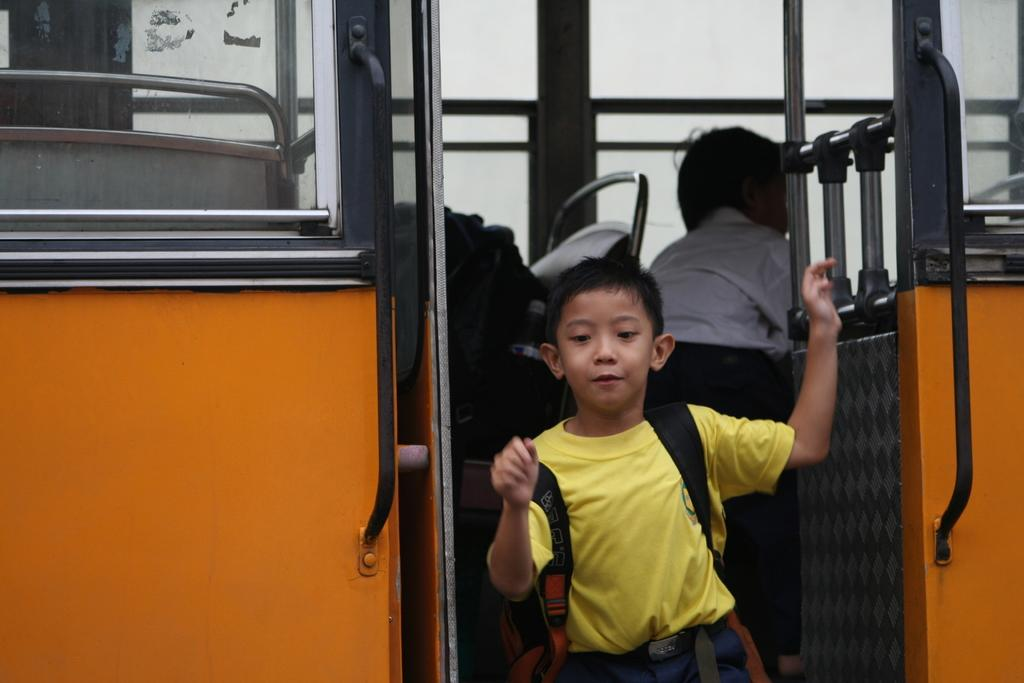Who is the main subject in the image? There is a boy in the image. What is the boy doing in the image? The boy is getting down from a bus. Is there anyone else present in the image? Yes, there is another boy standing behind him. What type of pen is the boy holding in the image? There is no pen present in the image; the boy is getting down from a bus. How does the fish react to the boy's presence in the image? There is no fish present in the image, so it cannot react to the boy's presence. 